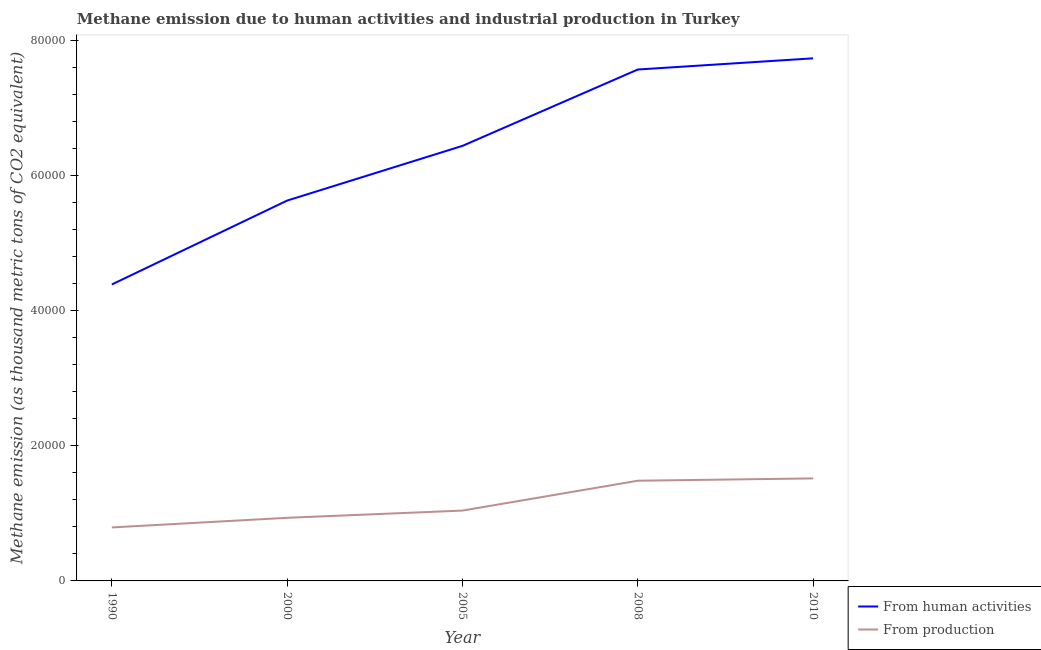What is the amount of emissions generated from industries in 2010?
Your response must be concise. 1.52e+04. Across all years, what is the maximum amount of emissions generated from industries?
Ensure brevity in your answer.  1.52e+04. Across all years, what is the minimum amount of emissions generated from industries?
Keep it short and to the point. 7912.1. In which year was the amount of emissions from human activities maximum?
Your answer should be compact. 2010. In which year was the amount of emissions generated from industries minimum?
Ensure brevity in your answer.  1990. What is the total amount of emissions from human activities in the graph?
Offer a very short reply. 3.17e+05. What is the difference between the amount of emissions generated from industries in 2005 and that in 2010?
Provide a short and direct response. -4759.2. What is the difference between the amount of emissions generated from industries in 1990 and the amount of emissions from human activities in 2005?
Your answer should be compact. -5.64e+04. What is the average amount of emissions generated from industries per year?
Give a very brief answer. 1.15e+04. In the year 2000, what is the difference between the amount of emissions generated from industries and amount of emissions from human activities?
Give a very brief answer. -4.69e+04. What is the ratio of the amount of emissions from human activities in 1990 to that in 2008?
Your response must be concise. 0.58. Is the difference between the amount of emissions from human activities in 2000 and 2008 greater than the difference between the amount of emissions generated from industries in 2000 and 2008?
Keep it short and to the point. No. What is the difference between the highest and the second highest amount of emissions from human activities?
Your answer should be very brief. 1655.4. What is the difference between the highest and the lowest amount of emissions generated from industries?
Ensure brevity in your answer.  7253.5. Is the sum of the amount of emissions from human activities in 1990 and 2010 greater than the maximum amount of emissions generated from industries across all years?
Keep it short and to the point. Yes. Does the amount of emissions generated from industries monotonically increase over the years?
Give a very brief answer. Yes. Is the amount of emissions generated from industries strictly greater than the amount of emissions from human activities over the years?
Make the answer very short. No. How many lines are there?
Provide a short and direct response. 2. What is the difference between two consecutive major ticks on the Y-axis?
Your response must be concise. 2.00e+04. Are the values on the major ticks of Y-axis written in scientific E-notation?
Ensure brevity in your answer.  No. Does the graph contain any zero values?
Your response must be concise. No. How are the legend labels stacked?
Provide a succinct answer. Vertical. What is the title of the graph?
Give a very brief answer. Methane emission due to human activities and industrial production in Turkey. What is the label or title of the Y-axis?
Keep it short and to the point. Methane emission (as thousand metric tons of CO2 equivalent). What is the Methane emission (as thousand metric tons of CO2 equivalent) in From human activities in 1990?
Your answer should be very brief. 4.39e+04. What is the Methane emission (as thousand metric tons of CO2 equivalent) of From production in 1990?
Give a very brief answer. 7912.1. What is the Methane emission (as thousand metric tons of CO2 equivalent) of From human activities in 2000?
Keep it short and to the point. 5.63e+04. What is the Methane emission (as thousand metric tons of CO2 equivalent) in From production in 2000?
Ensure brevity in your answer.  9337. What is the Methane emission (as thousand metric tons of CO2 equivalent) of From human activities in 2005?
Your answer should be very brief. 6.44e+04. What is the Methane emission (as thousand metric tons of CO2 equivalent) in From production in 2005?
Your response must be concise. 1.04e+04. What is the Methane emission (as thousand metric tons of CO2 equivalent) in From human activities in 2008?
Your answer should be compact. 7.57e+04. What is the Methane emission (as thousand metric tons of CO2 equivalent) of From production in 2008?
Give a very brief answer. 1.48e+04. What is the Methane emission (as thousand metric tons of CO2 equivalent) of From human activities in 2010?
Give a very brief answer. 7.73e+04. What is the Methane emission (as thousand metric tons of CO2 equivalent) in From production in 2010?
Provide a succinct answer. 1.52e+04. Across all years, what is the maximum Methane emission (as thousand metric tons of CO2 equivalent) in From human activities?
Give a very brief answer. 7.73e+04. Across all years, what is the maximum Methane emission (as thousand metric tons of CO2 equivalent) of From production?
Provide a short and direct response. 1.52e+04. Across all years, what is the minimum Methane emission (as thousand metric tons of CO2 equivalent) in From human activities?
Offer a very short reply. 4.39e+04. Across all years, what is the minimum Methane emission (as thousand metric tons of CO2 equivalent) in From production?
Make the answer very short. 7912.1. What is the total Methane emission (as thousand metric tons of CO2 equivalent) in From human activities in the graph?
Provide a succinct answer. 3.17e+05. What is the total Methane emission (as thousand metric tons of CO2 equivalent) of From production in the graph?
Provide a succinct answer. 5.76e+04. What is the difference between the Methane emission (as thousand metric tons of CO2 equivalent) in From human activities in 1990 and that in 2000?
Make the answer very short. -1.24e+04. What is the difference between the Methane emission (as thousand metric tons of CO2 equivalent) in From production in 1990 and that in 2000?
Offer a terse response. -1424.9. What is the difference between the Methane emission (as thousand metric tons of CO2 equivalent) of From human activities in 1990 and that in 2005?
Offer a terse response. -2.05e+04. What is the difference between the Methane emission (as thousand metric tons of CO2 equivalent) of From production in 1990 and that in 2005?
Provide a succinct answer. -2494.3. What is the difference between the Methane emission (as thousand metric tons of CO2 equivalent) of From human activities in 1990 and that in 2008?
Provide a short and direct response. -3.18e+04. What is the difference between the Methane emission (as thousand metric tons of CO2 equivalent) in From production in 1990 and that in 2008?
Your answer should be very brief. -6910. What is the difference between the Methane emission (as thousand metric tons of CO2 equivalent) of From human activities in 1990 and that in 2010?
Offer a terse response. -3.35e+04. What is the difference between the Methane emission (as thousand metric tons of CO2 equivalent) of From production in 1990 and that in 2010?
Give a very brief answer. -7253.5. What is the difference between the Methane emission (as thousand metric tons of CO2 equivalent) of From human activities in 2000 and that in 2005?
Provide a succinct answer. -8092.9. What is the difference between the Methane emission (as thousand metric tons of CO2 equivalent) of From production in 2000 and that in 2005?
Offer a very short reply. -1069.4. What is the difference between the Methane emission (as thousand metric tons of CO2 equivalent) in From human activities in 2000 and that in 2008?
Offer a terse response. -1.94e+04. What is the difference between the Methane emission (as thousand metric tons of CO2 equivalent) in From production in 2000 and that in 2008?
Make the answer very short. -5485.1. What is the difference between the Methane emission (as thousand metric tons of CO2 equivalent) in From human activities in 2000 and that in 2010?
Your response must be concise. -2.10e+04. What is the difference between the Methane emission (as thousand metric tons of CO2 equivalent) of From production in 2000 and that in 2010?
Ensure brevity in your answer.  -5828.6. What is the difference between the Methane emission (as thousand metric tons of CO2 equivalent) in From human activities in 2005 and that in 2008?
Keep it short and to the point. -1.13e+04. What is the difference between the Methane emission (as thousand metric tons of CO2 equivalent) in From production in 2005 and that in 2008?
Your response must be concise. -4415.7. What is the difference between the Methane emission (as thousand metric tons of CO2 equivalent) in From human activities in 2005 and that in 2010?
Your answer should be very brief. -1.30e+04. What is the difference between the Methane emission (as thousand metric tons of CO2 equivalent) of From production in 2005 and that in 2010?
Your answer should be very brief. -4759.2. What is the difference between the Methane emission (as thousand metric tons of CO2 equivalent) of From human activities in 2008 and that in 2010?
Ensure brevity in your answer.  -1655.4. What is the difference between the Methane emission (as thousand metric tons of CO2 equivalent) in From production in 2008 and that in 2010?
Ensure brevity in your answer.  -343.5. What is the difference between the Methane emission (as thousand metric tons of CO2 equivalent) of From human activities in 1990 and the Methane emission (as thousand metric tons of CO2 equivalent) of From production in 2000?
Your answer should be very brief. 3.45e+04. What is the difference between the Methane emission (as thousand metric tons of CO2 equivalent) of From human activities in 1990 and the Methane emission (as thousand metric tons of CO2 equivalent) of From production in 2005?
Provide a succinct answer. 3.34e+04. What is the difference between the Methane emission (as thousand metric tons of CO2 equivalent) in From human activities in 1990 and the Methane emission (as thousand metric tons of CO2 equivalent) in From production in 2008?
Offer a terse response. 2.90e+04. What is the difference between the Methane emission (as thousand metric tons of CO2 equivalent) in From human activities in 1990 and the Methane emission (as thousand metric tons of CO2 equivalent) in From production in 2010?
Make the answer very short. 2.87e+04. What is the difference between the Methane emission (as thousand metric tons of CO2 equivalent) in From human activities in 2000 and the Methane emission (as thousand metric tons of CO2 equivalent) in From production in 2005?
Your response must be concise. 4.59e+04. What is the difference between the Methane emission (as thousand metric tons of CO2 equivalent) of From human activities in 2000 and the Methane emission (as thousand metric tons of CO2 equivalent) of From production in 2008?
Offer a very short reply. 4.14e+04. What is the difference between the Methane emission (as thousand metric tons of CO2 equivalent) in From human activities in 2000 and the Methane emission (as thousand metric tons of CO2 equivalent) in From production in 2010?
Your answer should be compact. 4.11e+04. What is the difference between the Methane emission (as thousand metric tons of CO2 equivalent) of From human activities in 2005 and the Methane emission (as thousand metric tons of CO2 equivalent) of From production in 2008?
Your answer should be compact. 4.95e+04. What is the difference between the Methane emission (as thousand metric tons of CO2 equivalent) of From human activities in 2005 and the Methane emission (as thousand metric tons of CO2 equivalent) of From production in 2010?
Provide a short and direct response. 4.92e+04. What is the difference between the Methane emission (as thousand metric tons of CO2 equivalent) of From human activities in 2008 and the Methane emission (as thousand metric tons of CO2 equivalent) of From production in 2010?
Make the answer very short. 6.05e+04. What is the average Methane emission (as thousand metric tons of CO2 equivalent) in From human activities per year?
Make the answer very short. 6.35e+04. What is the average Methane emission (as thousand metric tons of CO2 equivalent) in From production per year?
Provide a succinct answer. 1.15e+04. In the year 1990, what is the difference between the Methane emission (as thousand metric tons of CO2 equivalent) in From human activities and Methane emission (as thousand metric tons of CO2 equivalent) in From production?
Keep it short and to the point. 3.59e+04. In the year 2000, what is the difference between the Methane emission (as thousand metric tons of CO2 equivalent) of From human activities and Methane emission (as thousand metric tons of CO2 equivalent) of From production?
Your response must be concise. 4.69e+04. In the year 2005, what is the difference between the Methane emission (as thousand metric tons of CO2 equivalent) in From human activities and Methane emission (as thousand metric tons of CO2 equivalent) in From production?
Offer a terse response. 5.40e+04. In the year 2008, what is the difference between the Methane emission (as thousand metric tons of CO2 equivalent) of From human activities and Methane emission (as thousand metric tons of CO2 equivalent) of From production?
Provide a short and direct response. 6.08e+04. In the year 2010, what is the difference between the Methane emission (as thousand metric tons of CO2 equivalent) of From human activities and Methane emission (as thousand metric tons of CO2 equivalent) of From production?
Give a very brief answer. 6.21e+04. What is the ratio of the Methane emission (as thousand metric tons of CO2 equivalent) of From human activities in 1990 to that in 2000?
Provide a succinct answer. 0.78. What is the ratio of the Methane emission (as thousand metric tons of CO2 equivalent) of From production in 1990 to that in 2000?
Give a very brief answer. 0.85. What is the ratio of the Methane emission (as thousand metric tons of CO2 equivalent) of From human activities in 1990 to that in 2005?
Your response must be concise. 0.68. What is the ratio of the Methane emission (as thousand metric tons of CO2 equivalent) in From production in 1990 to that in 2005?
Your response must be concise. 0.76. What is the ratio of the Methane emission (as thousand metric tons of CO2 equivalent) in From human activities in 1990 to that in 2008?
Your response must be concise. 0.58. What is the ratio of the Methane emission (as thousand metric tons of CO2 equivalent) in From production in 1990 to that in 2008?
Offer a terse response. 0.53. What is the ratio of the Methane emission (as thousand metric tons of CO2 equivalent) of From human activities in 1990 to that in 2010?
Your answer should be compact. 0.57. What is the ratio of the Methane emission (as thousand metric tons of CO2 equivalent) in From production in 1990 to that in 2010?
Your answer should be compact. 0.52. What is the ratio of the Methane emission (as thousand metric tons of CO2 equivalent) in From human activities in 2000 to that in 2005?
Offer a very short reply. 0.87. What is the ratio of the Methane emission (as thousand metric tons of CO2 equivalent) of From production in 2000 to that in 2005?
Offer a terse response. 0.9. What is the ratio of the Methane emission (as thousand metric tons of CO2 equivalent) of From human activities in 2000 to that in 2008?
Provide a succinct answer. 0.74. What is the ratio of the Methane emission (as thousand metric tons of CO2 equivalent) of From production in 2000 to that in 2008?
Offer a terse response. 0.63. What is the ratio of the Methane emission (as thousand metric tons of CO2 equivalent) in From human activities in 2000 to that in 2010?
Keep it short and to the point. 0.73. What is the ratio of the Methane emission (as thousand metric tons of CO2 equivalent) in From production in 2000 to that in 2010?
Offer a terse response. 0.62. What is the ratio of the Methane emission (as thousand metric tons of CO2 equivalent) in From human activities in 2005 to that in 2008?
Provide a short and direct response. 0.85. What is the ratio of the Methane emission (as thousand metric tons of CO2 equivalent) in From production in 2005 to that in 2008?
Your answer should be very brief. 0.7. What is the ratio of the Methane emission (as thousand metric tons of CO2 equivalent) in From human activities in 2005 to that in 2010?
Ensure brevity in your answer.  0.83. What is the ratio of the Methane emission (as thousand metric tons of CO2 equivalent) in From production in 2005 to that in 2010?
Keep it short and to the point. 0.69. What is the ratio of the Methane emission (as thousand metric tons of CO2 equivalent) of From human activities in 2008 to that in 2010?
Offer a very short reply. 0.98. What is the ratio of the Methane emission (as thousand metric tons of CO2 equivalent) in From production in 2008 to that in 2010?
Offer a very short reply. 0.98. What is the difference between the highest and the second highest Methane emission (as thousand metric tons of CO2 equivalent) in From human activities?
Offer a terse response. 1655.4. What is the difference between the highest and the second highest Methane emission (as thousand metric tons of CO2 equivalent) of From production?
Give a very brief answer. 343.5. What is the difference between the highest and the lowest Methane emission (as thousand metric tons of CO2 equivalent) of From human activities?
Your answer should be very brief. 3.35e+04. What is the difference between the highest and the lowest Methane emission (as thousand metric tons of CO2 equivalent) of From production?
Your response must be concise. 7253.5. 